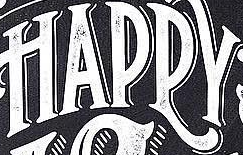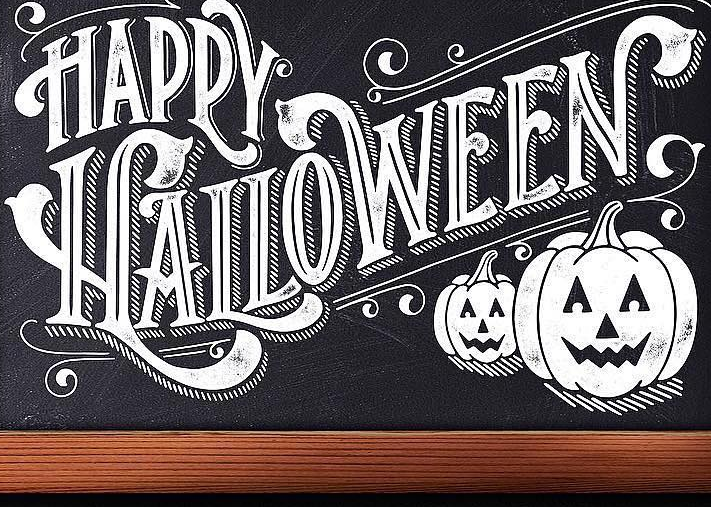What text is displayed in these images sequentially, separated by a semicolon? HAPPY; HALLOWEEN 